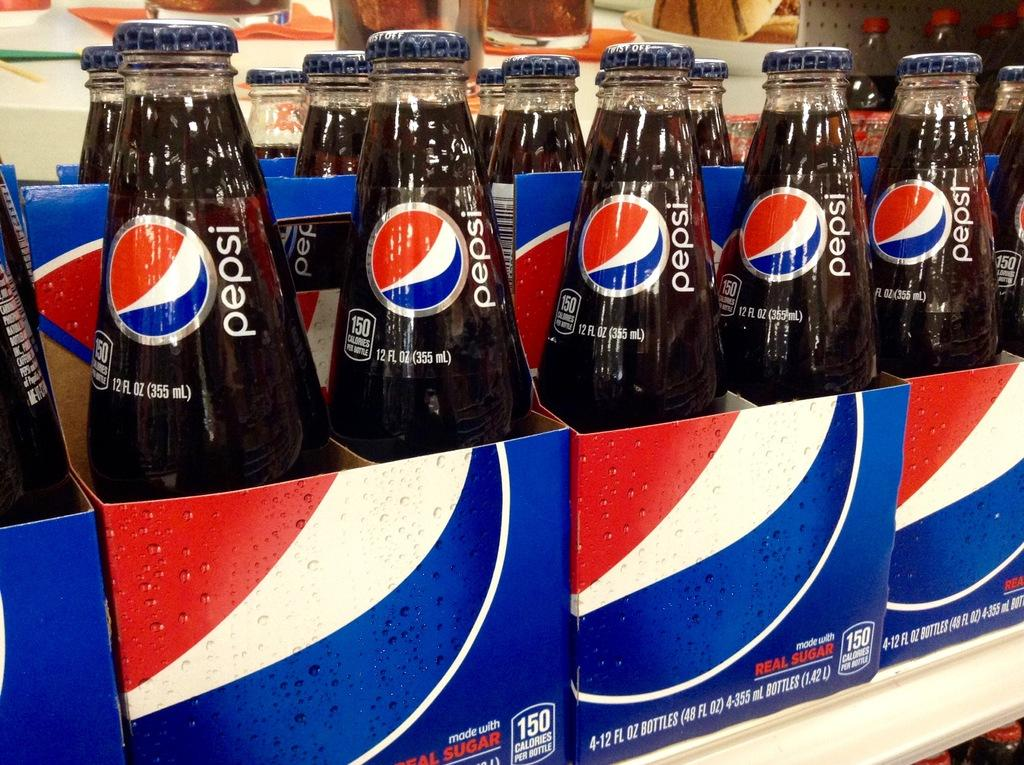<image>
Offer a succinct explanation of the picture presented. Pepsi bottles inside of boxes being sold for sale. 